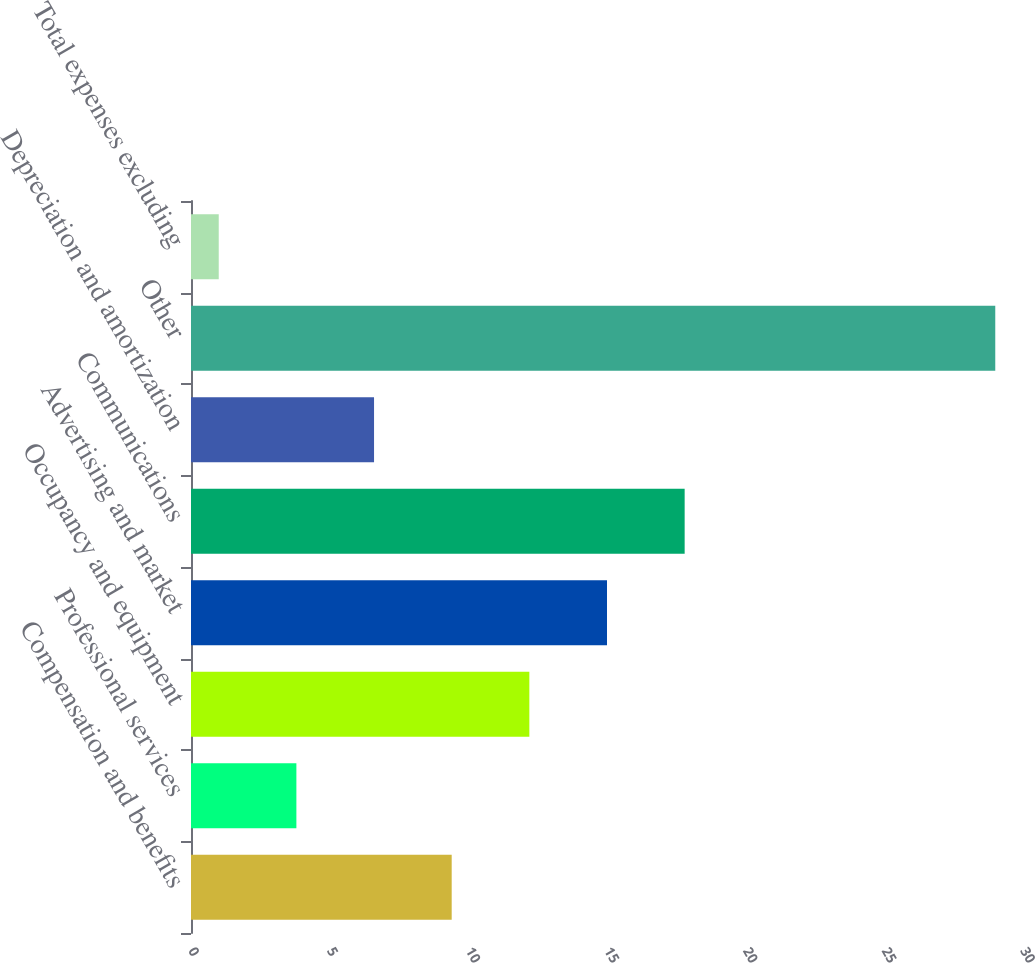<chart> <loc_0><loc_0><loc_500><loc_500><bar_chart><fcel>Compensation and benefits<fcel>Professional services<fcel>Occupancy and equipment<fcel>Advertising and market<fcel>Communications<fcel>Depreciation and amortization<fcel>Other<fcel>Total expenses excluding<nl><fcel>9.4<fcel>3.8<fcel>12.2<fcel>15<fcel>17.8<fcel>6.6<fcel>29<fcel>1<nl></chart> 